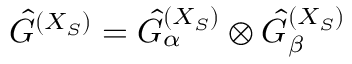<formula> <loc_0><loc_0><loc_500><loc_500>\hat { G } ^ { ( X _ { S } ) } = \hat { G } _ { \alpha } ^ { ( X _ { S } ) } \otimes \hat { G } _ { \beta } ^ { ( X _ { S } ) }</formula> 